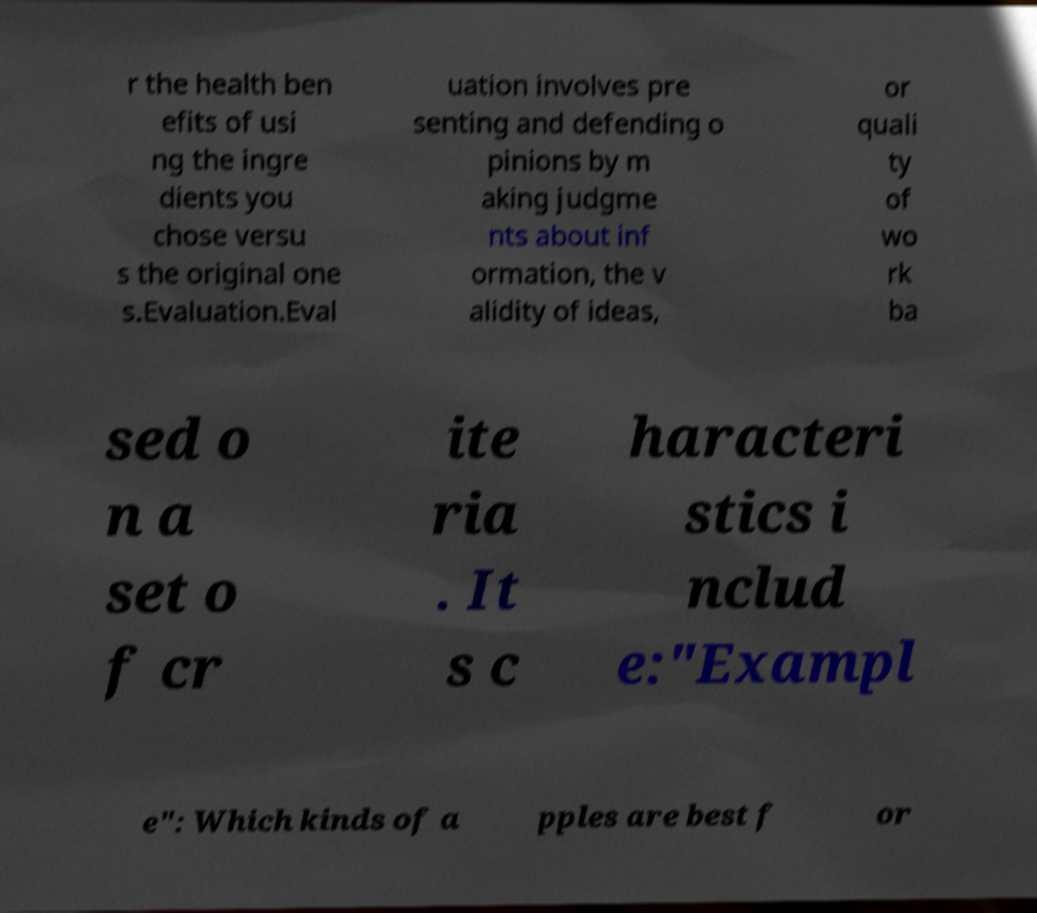Could you extract and type out the text from this image? r the health ben efits of usi ng the ingre dients you chose versu s the original one s.Evaluation.Eval uation involves pre senting and defending o pinions by m aking judgme nts about inf ormation, the v alidity of ideas, or quali ty of wo rk ba sed o n a set o f cr ite ria . It s c haracteri stics i nclud e:"Exampl e": Which kinds of a pples are best f or 